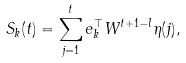<formula> <loc_0><loc_0><loc_500><loc_500>S _ { k } ( t ) = \sum _ { j = 1 } ^ { t } e _ { k } ^ { \top } W ^ { t + 1 - l } \eta ( j ) ,</formula> 